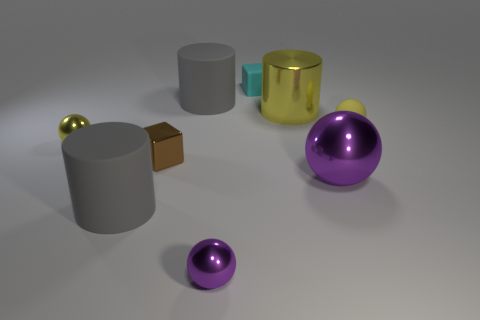Add 1 big shiny cylinders. How many objects exist? 10 Subtract all spheres. How many objects are left? 5 Subtract 1 cyan blocks. How many objects are left? 8 Subtract all tiny blocks. Subtract all big metallic cylinders. How many objects are left? 6 Add 1 big yellow cylinders. How many big yellow cylinders are left? 2 Add 2 big yellow things. How many big yellow things exist? 3 